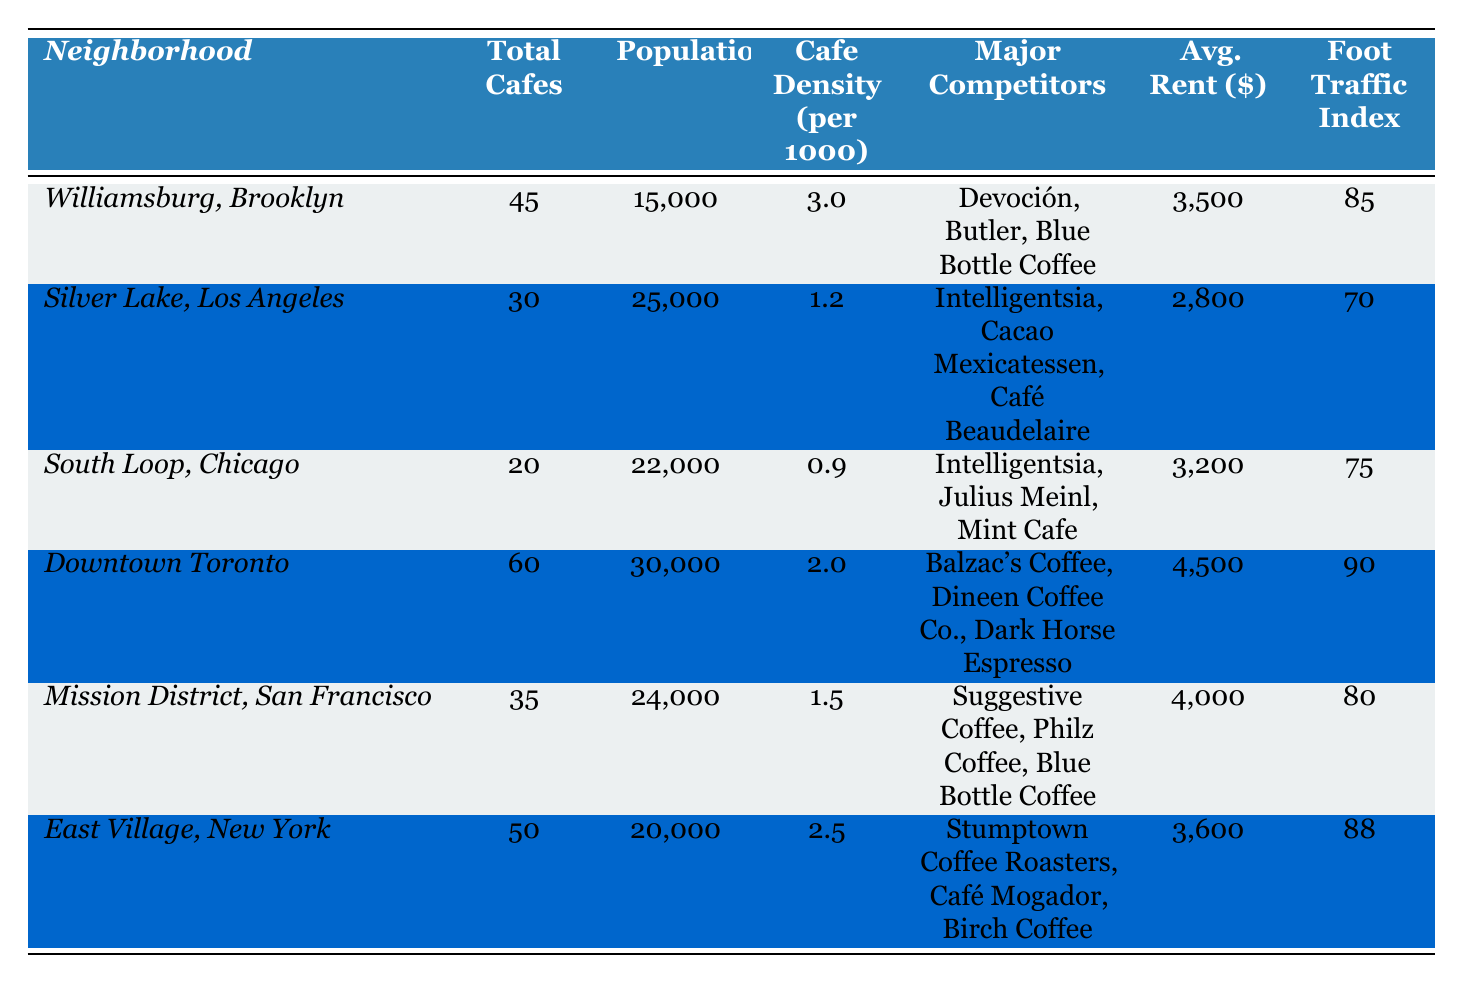What is the cafe density per 1000 people in Williamsburg, Brooklyn? The table shows that Williamsburg, Brooklyn has a cafe density of 3.0 per 1000 people.
Answer: 3.0 Which neighborhood has the highest number of cafes? The table lists Downtown Toronto with a total of 60 cafes, which is more than any other neighborhood.
Answer: Downtown Toronto What is the average rent for cafes in Silver Lake, Los Angeles? According to the table, the average rent for cafes in Silver Lake, Los Angeles is $2,800.
Answer: $2,800 Is East Village, New York the neighborhood with the highest foot traffic index? The table indicates that Downtown Toronto has a foot traffic index of 90, which is higher than East Village's 88.
Answer: No What is the total number of cafes in neighborhoods with a population over 20,000? In the neighborhoods with a population over 20,000 (Silver Lake, South Loop, Downtown Toronto, and Mission District), the total number of cafes is 30 + 20 + 60 + 35 = 145.
Answer: 145 Which neighborhood has the lowest cafe density? The table reveals that South Loop, Chicago has the lowest cafe density at 0.9 per 1000 people.
Answer: South Loop, Chicago What is the difference in average rent between Downtown Toronto and South Loop, Chicago? The average rent in Downtown Toronto is $4,500 and in South Loop, Chicago is $3,200. The difference is $4,500 - $3,200 = $1,300.
Answer: $1,300 Are there any neighborhood competitors that are the same across different areas? The table mentions Blue Bottle Coffee as a major competitor in both Williamsburg, Brooklyn and Mission District, San Francisco, indicating a common competitor.
Answer: Yes Which neighborhood has the highest cafe density and what is that value? The cafe density in Williamsburg, Brooklyn is 3.0, which is the highest when comparing all neighborhoods in the table.
Answer: Williamsburg, Brooklyn, 3.0 How many total cafes are there in neighborhoods with an average rent below $3,500? The neighborhoods with average rent below $3,500 are Silver Lake and South Loop with 30 and 20 cafes, respectively, totaling 30 + 20 = 50 cafes.
Answer: 50 